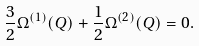Convert formula to latex. <formula><loc_0><loc_0><loc_500><loc_500>\frac { 3 } { 2 } \Omega ^ { ( 1 ) } ( Q ) + \frac { 1 } { 2 } \Omega ^ { ( 2 ) } ( Q ) = 0 .</formula> 